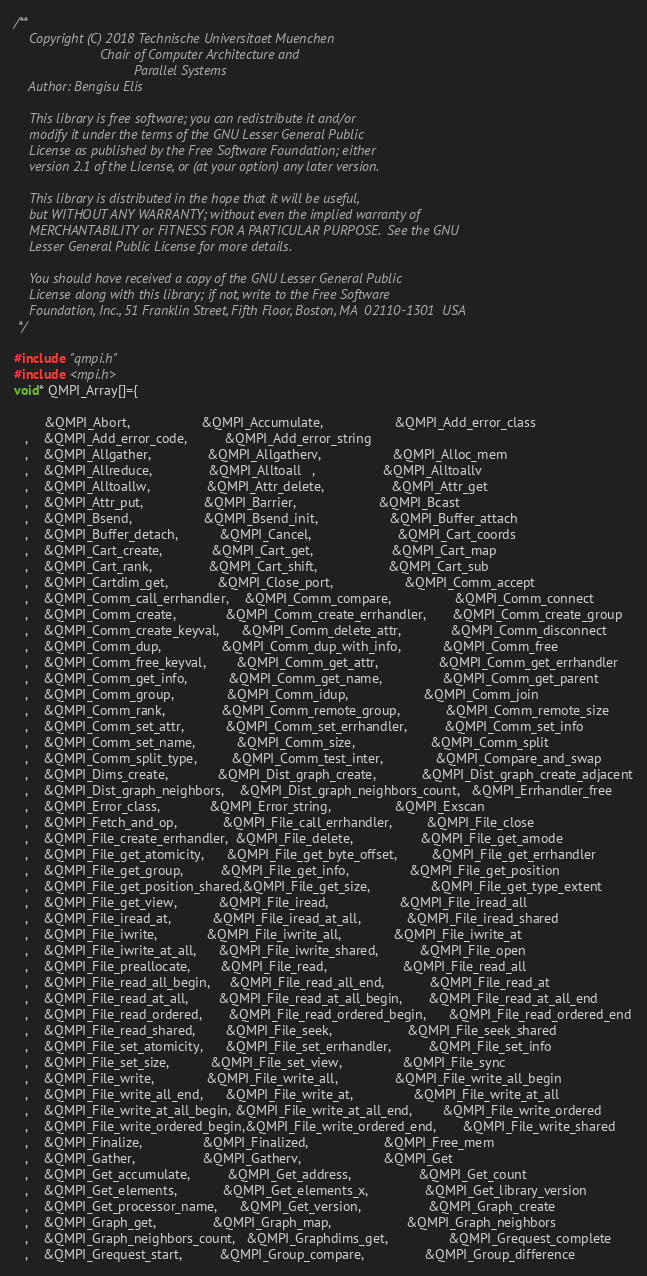Convert code to text. <code><loc_0><loc_0><loc_500><loc_500><_C_>/**
    Copyright (C) 2018 Technische Universitaet Muenchen
                       Chair of Computer Architecture and 
                                Parallel Systems
    Author: Bengisu Elis
    
    This library is free software; you can redistribute it and/or
    modify it under the terms of the GNU Lesser General Public
    License as published by the Free Software Foundation; either
    version 2.1 of the License, or (at your option) any later version.

    This library is distributed in the hope that it will be useful,
    but WITHOUT ANY WARRANTY; without even the implied warranty of
    MERCHANTABILITY or FITNESS FOR A PARTICULAR PURPOSE.  See the GNU
    Lesser General Public License for more details.

    You should have received a copy of the GNU Lesser General Public
    License along with this library; if not, write to the Free Software
    Foundation, Inc., 51 Franklin Street, Fifth Floor, Boston, MA  02110-1301  USA
 */

#include "qmpi.h"
#include <mpi.h>
void* QMPI_Array[]={  
  
        &QMPI_Abort,                   &QMPI_Accumulate,                   &QMPI_Add_error_class
   ,    &QMPI_Add_error_code,          &QMPI_Add_error_string
   ,    &QMPI_Allgather,               &QMPI_Allgatherv,                   &QMPI_Alloc_mem
   ,    &QMPI_Allreduce,               &QMPI_Alltoall   ,                  &QMPI_Alltoallv
   ,    &QMPI_Alltoallw,               &QMPI_Attr_delete,                  &QMPI_Attr_get
   ,    &QMPI_Attr_put,                &QMPI_Barrier,                      &QMPI_Bcast
   ,    &QMPI_Bsend,                   &QMPI_Bsend_init,                   &QMPI_Buffer_attach
   ,    &QMPI_Buffer_detach,           &QMPI_Cancel,                       &QMPI_Cart_coords
   ,    &QMPI_Cart_create,             &QMPI_Cart_get,                     &QMPI_Cart_map
   ,    &QMPI_Cart_rank,               &QMPI_Cart_shift,                   &QMPI_Cart_sub
   ,    &QMPI_Cartdim_get,             &QMPI_Close_port,                   &QMPI_Comm_accept
   ,    &QMPI_Comm_call_errhandler,    &QMPI_Comm_compare,                 &QMPI_Comm_connect   
   ,    &QMPI_Comm_create,             &QMPI_Comm_create_errhandler,       &QMPI_Comm_create_group
   ,    &QMPI_Comm_create_keyval,      &QMPI_Comm_delete_attr,             &QMPI_Comm_disconnect
   ,    &QMPI_Comm_dup,                &QMPI_Comm_dup_with_info,           &QMPI_Comm_free
   ,    &QMPI_Comm_free_keyval,        &QMPI_Comm_get_attr,                &QMPI_Comm_get_errhandler
   ,    &QMPI_Comm_get_info,           &QMPI_Comm_get_name,                &QMPI_Comm_get_parent
   ,    &QMPI_Comm_group,              &QMPI_Comm_idup,                    &QMPI_Comm_join
   ,    &QMPI_Comm_rank,               &QMPI_Comm_remote_group,            &QMPI_Comm_remote_size
   ,    &QMPI_Comm_set_attr,           &QMPI_Comm_set_errhandler,          &QMPI_Comm_set_info
   ,    &QMPI_Comm_set_name,           &QMPI_Comm_size,                    &QMPI_Comm_split
   ,    &QMPI_Comm_split_type,         &QMPI_Comm_test_inter,              &QMPI_Compare_and_swap
   ,    &QMPI_Dims_create,             &QMPI_Dist_graph_create,            &QMPI_Dist_graph_create_adjacent
   ,    &QMPI_Dist_graph_neighbors,    &QMPI_Dist_graph_neighbors_count,   &QMPI_Errhandler_free
   ,    &QMPI_Error_class,             &QMPI_Error_string,                 &QMPI_Exscan
   ,    &QMPI_Fetch_and_op,            &QMPI_File_call_errhandler,         &QMPI_File_close
   ,    &QMPI_File_create_errhandler,  &QMPI_File_delete,                  &QMPI_File_get_amode
   ,    &QMPI_File_get_atomicity,      &QMPI_File_get_byte_offset,         &QMPI_File_get_errhandler
   ,    &QMPI_File_get_group,          &QMPI_File_get_info,                &QMPI_File_get_position
   ,    &QMPI_File_get_position_shared,&QMPI_File_get_size,                &QMPI_File_get_type_extent
   ,    &QMPI_File_get_view,           &QMPI_File_iread,                   &QMPI_File_iread_all
   ,    &QMPI_File_iread_at,           &QMPI_File_iread_at_all,            &QMPI_File_iread_shared
   ,    &QMPI_File_iwrite,             &QMPI_File_iwrite_all,              &QMPI_File_iwrite_at
   ,    &QMPI_File_iwrite_at_all,      &QMPI_File_iwrite_shared,           &QMPI_File_open
   ,    &QMPI_File_preallocate,        &QMPI_File_read,                    &QMPI_File_read_all
   ,    &QMPI_File_read_all_begin,     &QMPI_File_read_all_end,            &QMPI_File_read_at
   ,    &QMPI_File_read_at_all,        &QMPI_File_read_at_all_begin,       &QMPI_File_read_at_all_end
   ,    &QMPI_File_read_ordered,       &QMPI_File_read_ordered_begin,      &QMPI_File_read_ordered_end
   ,    &QMPI_File_read_shared,        &QMPI_File_seek,                    &QMPI_File_seek_shared
   ,    &QMPI_File_set_atomicity,      &QMPI_File_set_errhandler,          &QMPI_File_set_info
   ,    &QMPI_File_set_size,           &QMPI_File_set_view,                &QMPI_File_sync
   ,    &QMPI_File_write,              &QMPI_File_write_all,               &QMPI_File_write_all_begin
   ,    &QMPI_File_write_all_end,      &QMPI_File_write_at,                &QMPI_File_write_at_all
   ,    &QMPI_File_write_at_all_begin, &QMPI_File_write_at_all_end,        &QMPI_File_write_ordered
   ,    &QMPI_File_write_ordered_begin,&QMPI_File_write_ordered_end,       &QMPI_File_write_shared
   ,    &QMPI_Finalize,                &QMPI_Finalized,                    &QMPI_Free_mem
   ,    &QMPI_Gather,                  &QMPI_Gatherv,                      &QMPI_Get
   ,    &QMPI_Get_accumulate,          &QMPI_Get_address,                  &QMPI_Get_count
   ,    &QMPI_Get_elements,            &QMPI_Get_elements_x,               &QMPI_Get_library_version
   ,    &QMPI_Get_processor_name,      &QMPI_Get_version,                  &QMPI_Graph_create
   ,    &QMPI_Graph_get,               &QMPI_Graph_map,                    &QMPI_Graph_neighbors 
   ,    &QMPI_Graph_neighbors_count,   &QMPI_Graphdims_get,                &QMPI_Grequest_complete
   ,    &QMPI_Grequest_start,          &QMPI_Group_compare,                &QMPI_Group_difference</code> 